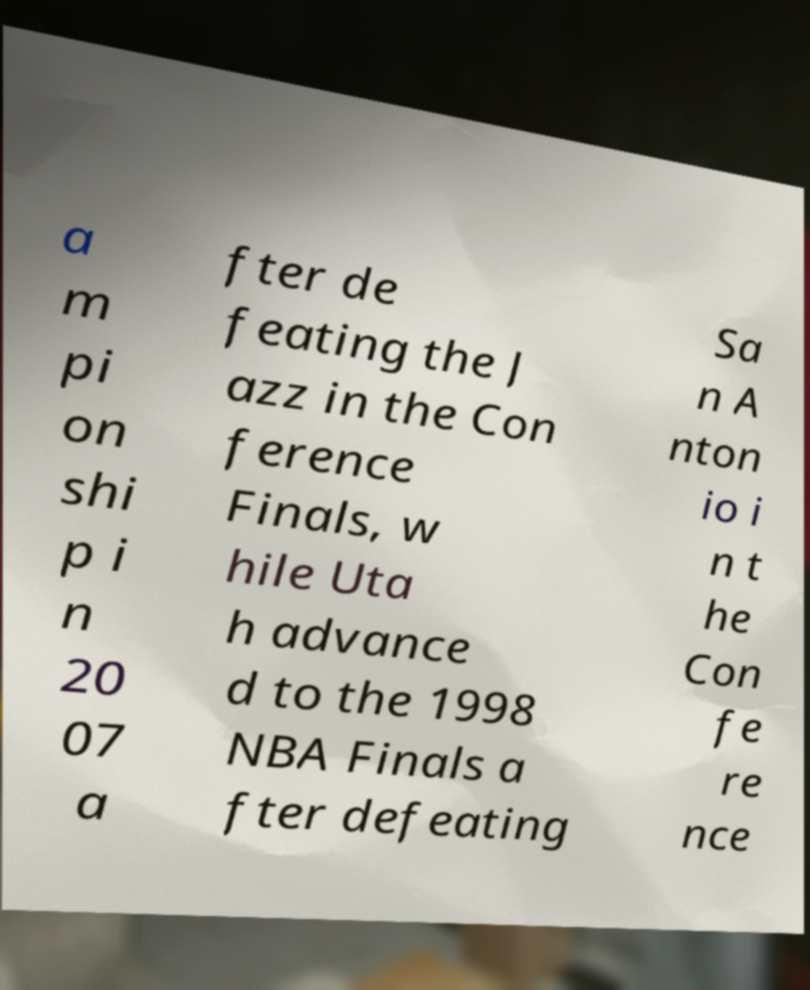I need the written content from this picture converted into text. Can you do that? a m pi on shi p i n 20 07 a fter de feating the J azz in the Con ference Finals, w hile Uta h advance d to the 1998 NBA Finals a fter defeating Sa n A nton io i n t he Con fe re nce 